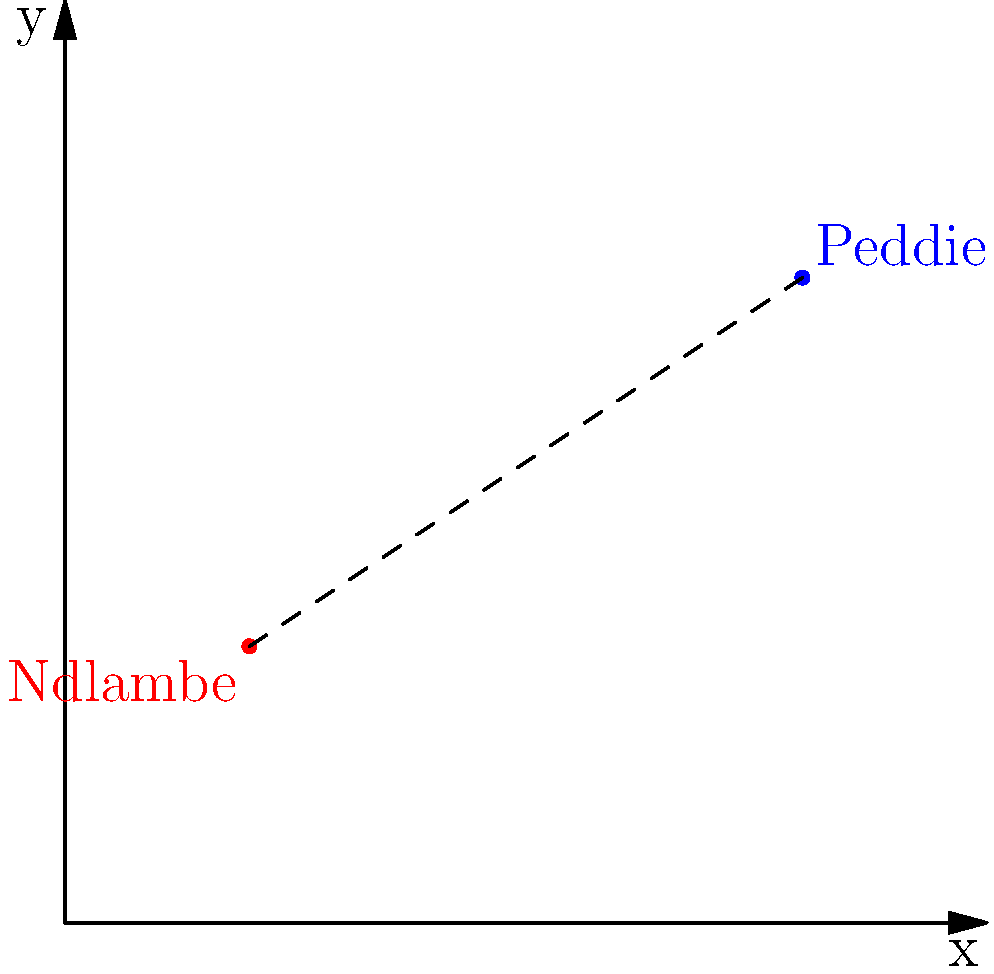Two villages, Ndlambe and Peddie, are located on a map using a Cartesian coordinate system. Ndlambe is at (2, 3) and Peddie is at (8, 7). What is the straight-line distance between these two villages? Round your answer to the nearest kilometer. To find the distance between two points on a Cartesian coordinate system, we can use the distance formula:

$$d = \sqrt{(x_2 - x_1)^2 + (y_2 - y_1)^2}$$

Where $(x_1, y_1)$ are the coordinates of the first point and $(x_2, y_2)$ are the coordinates of the second point.

Let's plug in our values:
$(x_1, y_1) = (2, 3)$ for Ndlambe
$(x_2, y_2) = (8, 7)$ for Peddie

Now, let's calculate:

1) $d = \sqrt{(8 - 2)^2 + (7 - 3)^2}$
2) $d = \sqrt{6^2 + 4^2}$
3) $d = \sqrt{36 + 16}$
4) $d = \sqrt{52}$
5) $d \approx 7.211$ km

Rounding to the nearest kilometer, we get 7 km.
Answer: 7 km 